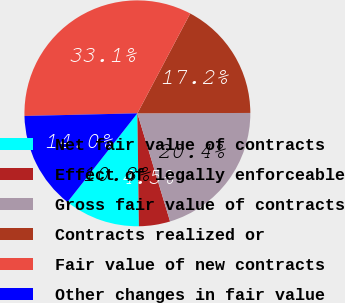Convert chart. <chart><loc_0><loc_0><loc_500><loc_500><pie_chart><fcel>Net fair value of contracts<fcel>Effect of legally enforceable<fcel>Gross fair value of contracts<fcel>Contracts realized or<fcel>Fair value of new contracts<fcel>Other changes in fair value<nl><fcel>10.83%<fcel>4.46%<fcel>20.38%<fcel>17.2%<fcel>33.12%<fcel>14.01%<nl></chart> 